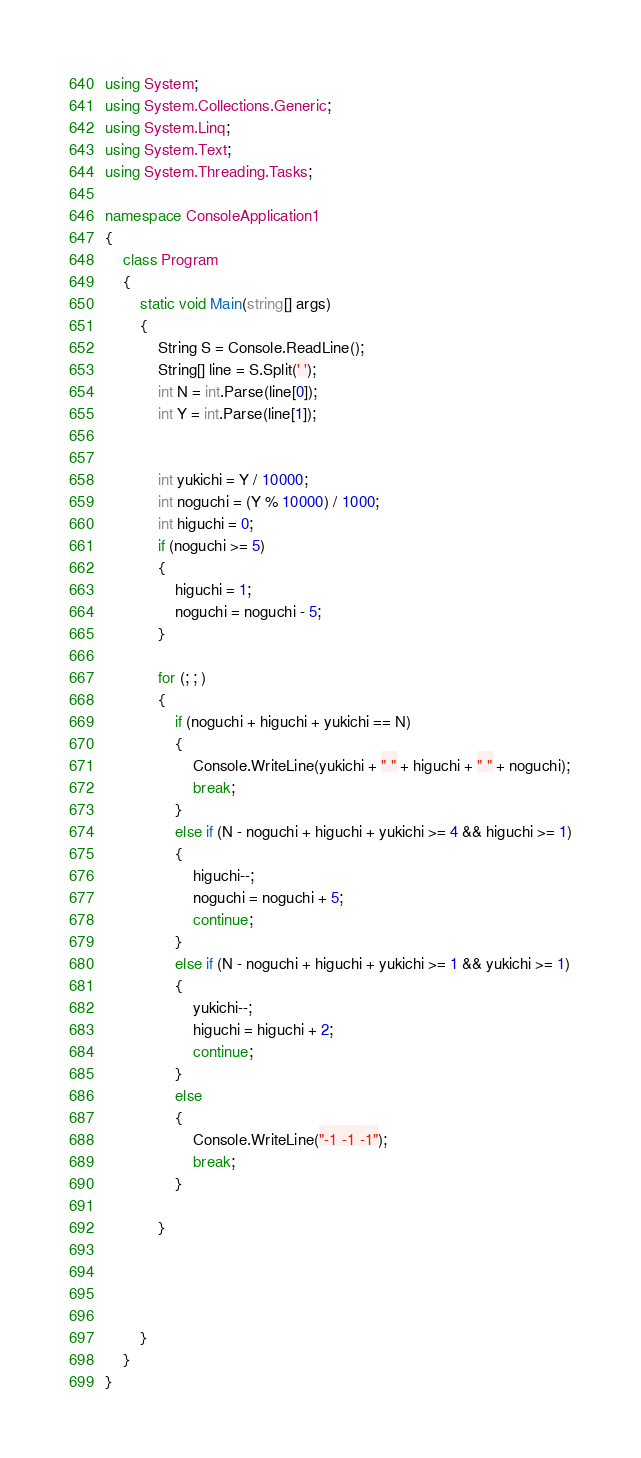Convert code to text. <code><loc_0><loc_0><loc_500><loc_500><_C#_>using System;
using System.Collections.Generic;
using System.Linq;
using System.Text;
using System.Threading.Tasks;

namespace ConsoleApplication1
{
    class Program
    {
        static void Main(string[] args)
        {
            String S = Console.ReadLine();
            String[] line = S.Split(' ');
            int N = int.Parse(line[0]);
            int Y = int.Parse(line[1]);


            int yukichi = Y / 10000;
            int noguchi = (Y % 10000) / 1000;
            int higuchi = 0;
            if (noguchi >= 5)
            {
                higuchi = 1;
                noguchi = noguchi - 5;
            }

            for (; ; )
            {
                if (noguchi + higuchi + yukichi == N)
                {
                    Console.WriteLine(yukichi + " " + higuchi + " " + noguchi);
                    break;
                }
                else if (N - noguchi + higuchi + yukichi >= 4 && higuchi >= 1)
                {
                    higuchi--;
                    noguchi = noguchi + 5;
                    continue;
                }
                else if (N - noguchi + higuchi + yukichi >= 1 && yukichi >= 1)
                {
                    yukichi--;
                    higuchi = higuchi + 2;
                    continue;
                }
                else
                {
                    Console.WriteLine("-1 -1 -1");
                    break;
                }

            }




        }
    }
}
</code> 